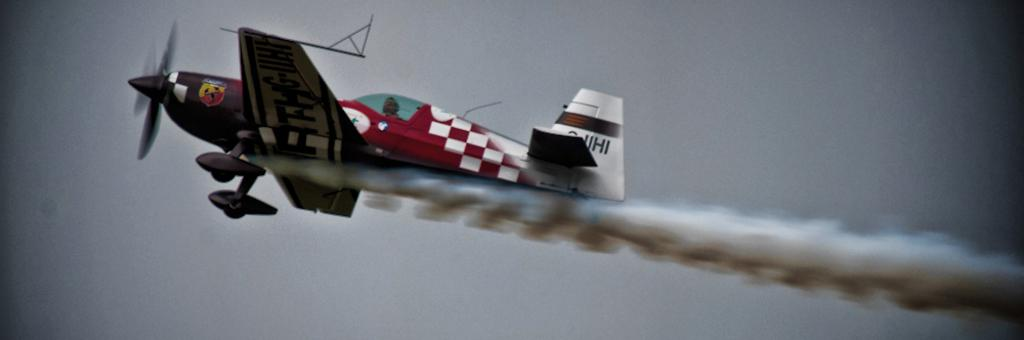What is the main subject of the picture? The main subject of the picture is an aircraft. What is the aircraft doing in the image? The aircraft is flying in the air and leaving a smoke trail. What is the color of the aircraft? The aircraft is red in color. Are there any unique features on the aircraft? Yes, the aircraft has designs on it. Can you tell me how many apples are on the aircraft in the image? There are no apples present on the aircraft in the image. Are there any women visible near the aircraft in the image? The provided facts do not mention any women in the image, so we cannot confirm their presence. 